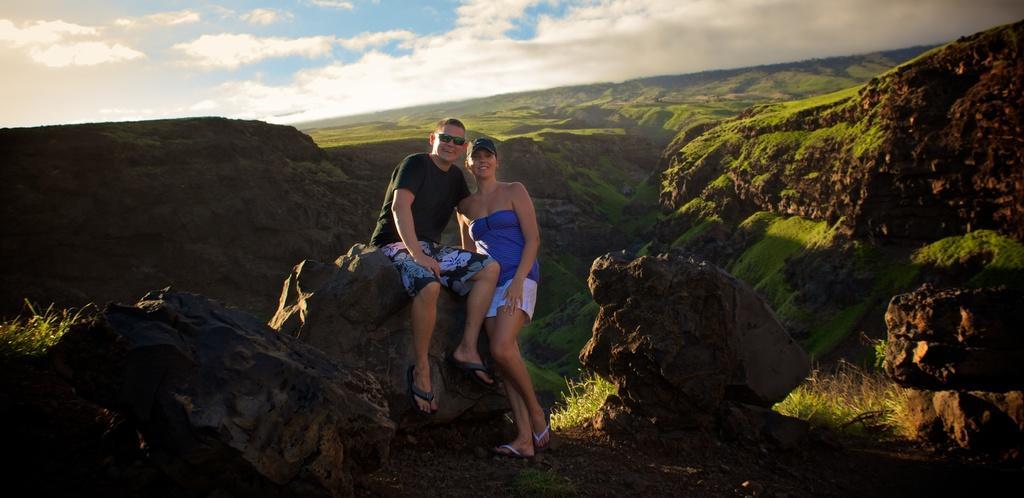Please provide a concise description of this image. In this image I can see a person wearing black t shirt and a woman wearing blue and white dress is standing and the person is sitting on a rock. In the background I can see few mountains, some grass and the sky. 